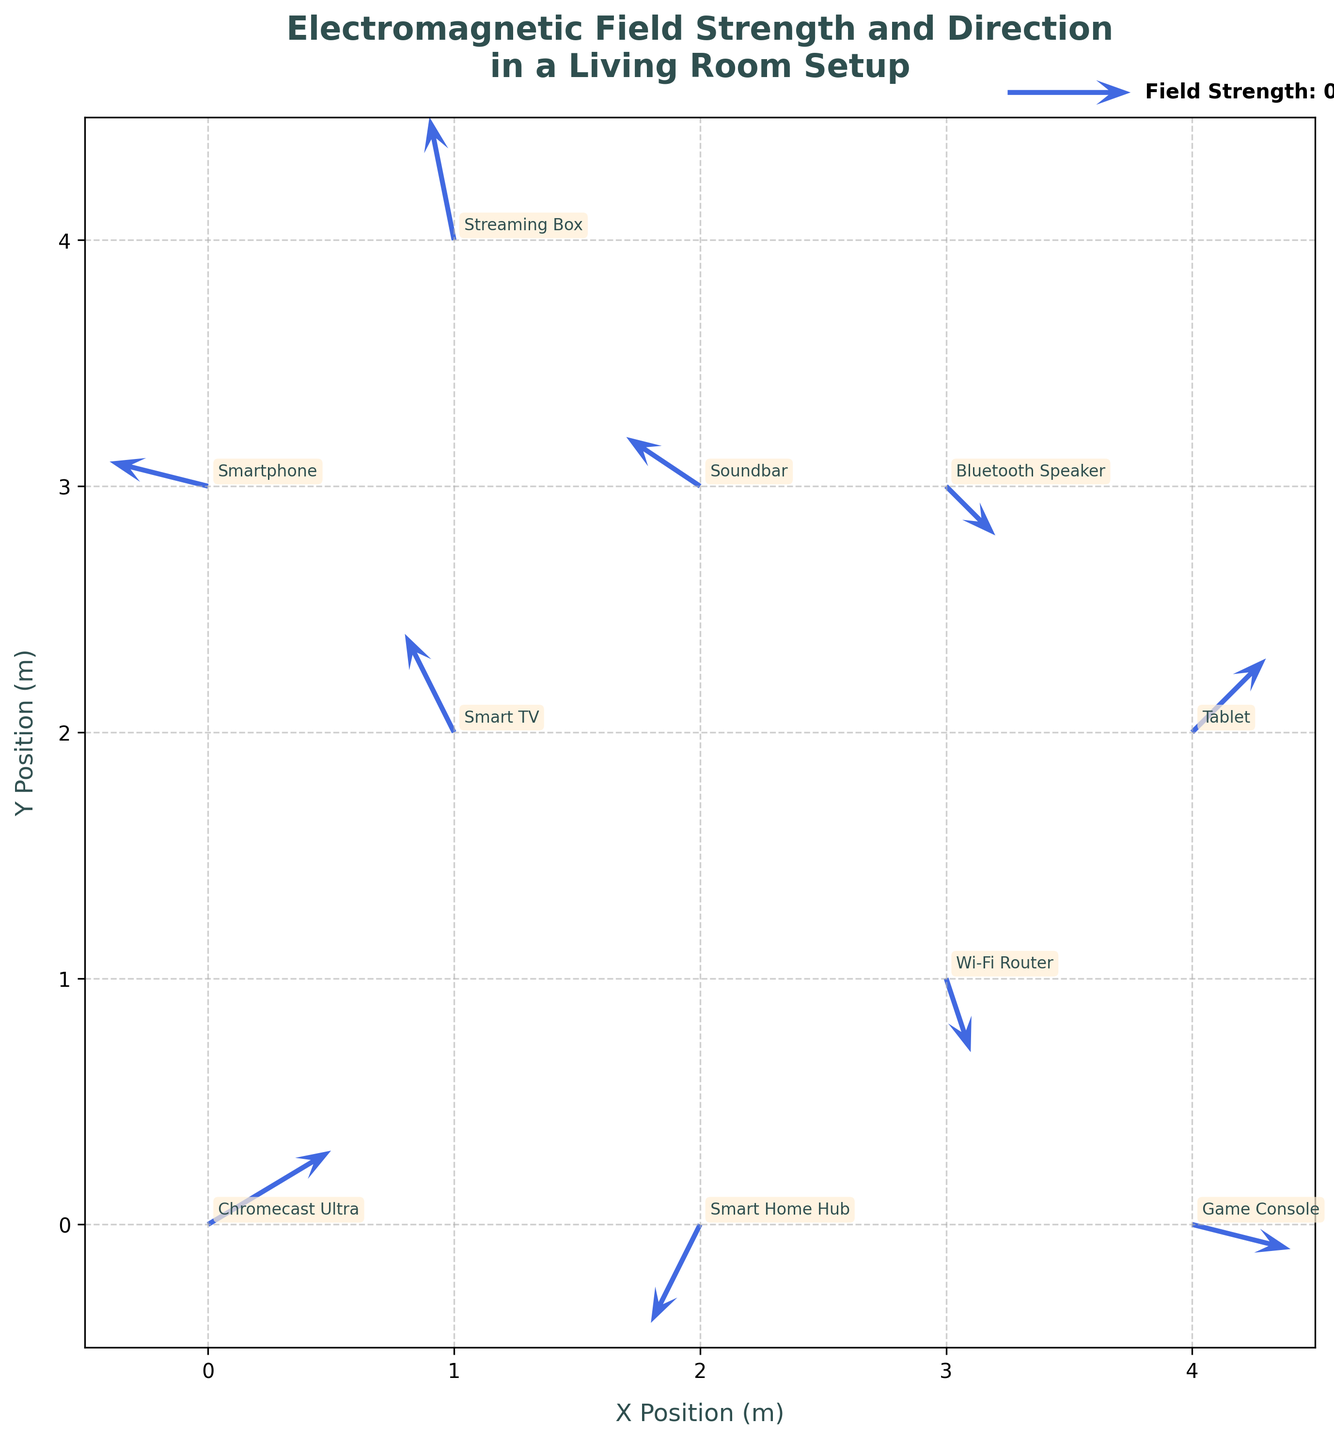How many devices are indicated in the plot? Count the number of unique data points, each representing a different device labeled in the plot. The devices are labeled with their names, such as "Chromecast Ultra", "Smart TV", etc.
Answer: 10 Which device has the largest magnitude of electromagnetic field components (dx, dy)? Calculate the magnitude for each device using the formula sqrt(dx^2 + dy^2). Compare these values to determine the largest. For instance, the magnitude for Chromecast Ultra is sqrt(0.5^2 + 0.3^2), while for the Smart TV, it’s sqrt((-0.2)^2 + 0.4^2). The Game Console has a magnitude sqrt(0.4^2 + (-0.1)^2), which is the largest.
Answer: Game Console Which direction does the electromagnetic field vector point towards for the Wi-Fi Router? Examine the orientation of the vector at the coordinates corresponding to the Wi-Fi Router. It points from the tail to the head of the vector (0.1, -0.3).
Answer: Mostly downward-left Where is the Streaming Box located in the plot? Check the plot for the label "Streaming Box" and read off its (x, y) coordinates. The Streaming Box is labeled at coordinates (1, 4).
Answer: (1, 4) In which quadrant of the plot is the Smart TV located? Determine which quadrant the coordinates of the Smart TV fall into. The quadrants are divided by the x and y axes. The Smart TV is at (1, 2), which places it in the first quadrant.
Answer: First quadrant Compare the electromagnetic field directions for the Smart Home Hub and the Bluetooth Speaker. Are they pointing in the same direction? Check the vectors for each device. The Smart Home Hub's vector points in the direction of (-0.2, -0.4), while the Bluetooth Speaker's vector points in the direction of (0.2, -0.2). Compare these directions.
Answer: No What is the combined electromagnetic field vector if we sum the vectors from the Chromecast Ultra and the Soundbar? Add the dx and dy components of both vectors: Chromecast Ultra (0.5, 0.3) and Soundbar (-0.3, 0.2). Combined dx = 0.5 + (-0.3) = 0.2, Combined dy = 0.3 + 0.2 = 0.5.
Answer: (0.2, 0.5) How do the electromagnetic field directions of the Smartphone and Tablet compare? Examine the vectors for both devices. The Smartphone's vector points in the direction (-0.4, 0.1), and the Tablet's vector points (0.3, 0.3). While both have a component pointing right, they differ in their vertical components.
Answer: Different Which device has a vector with a negative component in both x and y directions? Identify the devices with vectors having both dx and dy negative. The Smart Home Hub has such a vector (-0.2, -0.4).
Answer: Smart Home Hub 